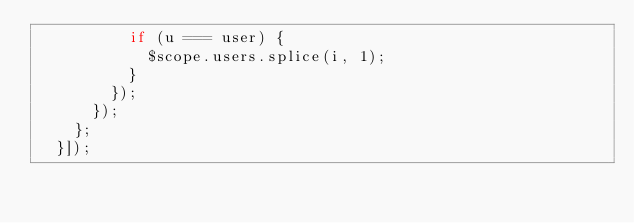Convert code to text. <code><loc_0><loc_0><loc_500><loc_500><_JavaScript_>          if (u === user) {
            $scope.users.splice(i, 1);
          }
        });
      });
    };
  }]);
</code> 